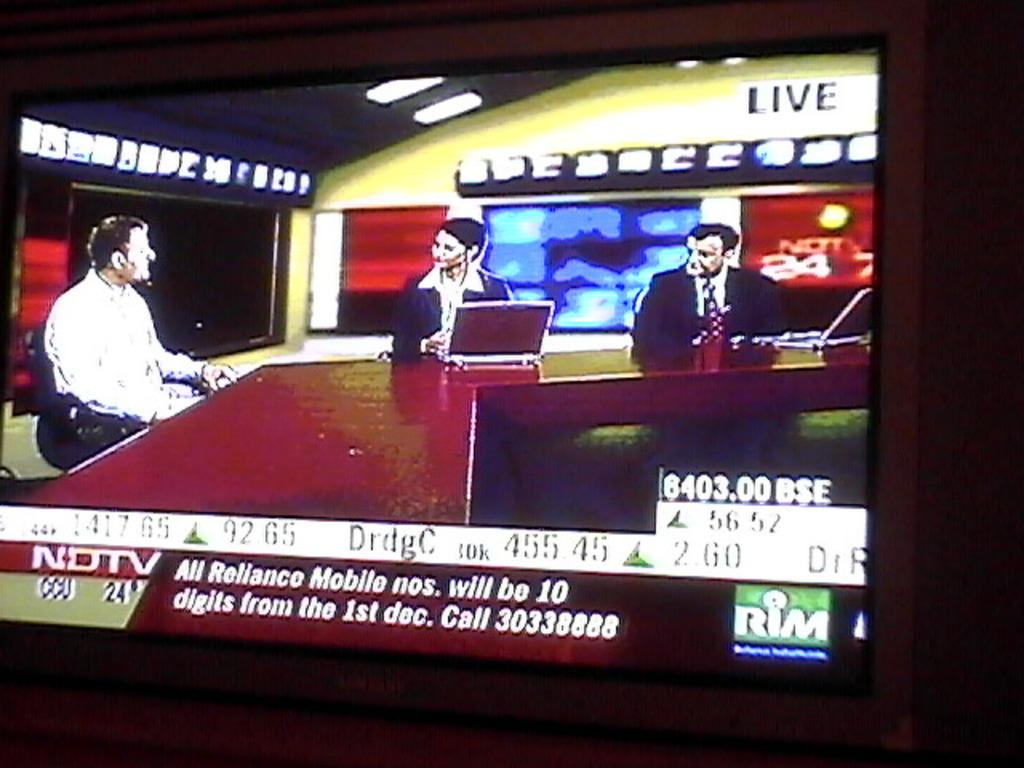<image>
Create a compact narrative representing the image presented. A shot of a tv with a news broadcast from NDTV on it. 